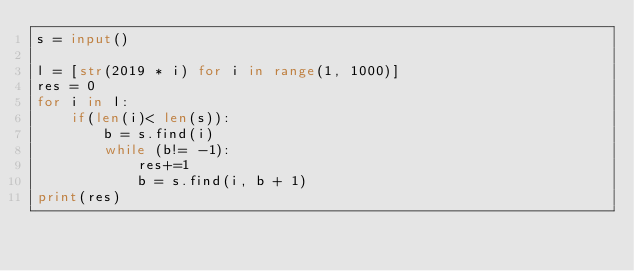Convert code to text. <code><loc_0><loc_0><loc_500><loc_500><_Python_>s = input()

l = [str(2019 * i) for i in range(1, 1000)]
res = 0
for i in l:
	if(len(i)< len(s)):
		b = s.find(i)
		while (b!= -1):
			res+=1
			b = s.find(i, b + 1)
print(res)</code> 